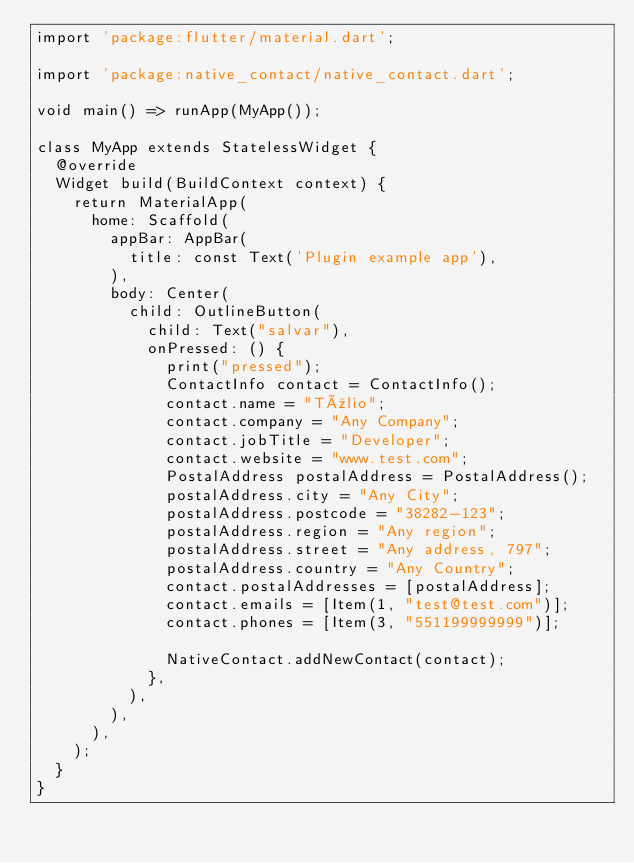Convert code to text. <code><loc_0><loc_0><loc_500><loc_500><_Dart_>import 'package:flutter/material.dart';

import 'package:native_contact/native_contact.dart';

void main() => runApp(MyApp());

class MyApp extends StatelessWidget {
  @override
  Widget build(BuildContext context) {
    return MaterialApp(
      home: Scaffold(
        appBar: AppBar(
          title: const Text('Plugin example app'),
        ),
        body: Center(
          child: OutlineButton(
            child: Text("salvar"),
            onPressed: () {
              print("pressed");
              ContactInfo contact = ContactInfo();
              contact.name = "Túlio";
              contact.company = "Any Company";
              contact.jobTitle = "Developer";
              contact.website = "www.test.com";
              PostalAddress postalAddress = PostalAddress();
              postalAddress.city = "Any City";
              postalAddress.postcode = "38282-123";
              postalAddress.region = "Any region";
              postalAddress.street = "Any address, 797";
              postalAddress.country = "Any Country";
              contact.postalAddresses = [postalAddress];
              contact.emails = [Item(1, "test@test.com")];
              contact.phones = [Item(3, "551199999999")];

              NativeContact.addNewContact(contact);
            },
          ),
        ),
      ),
    );
  }
}
</code> 